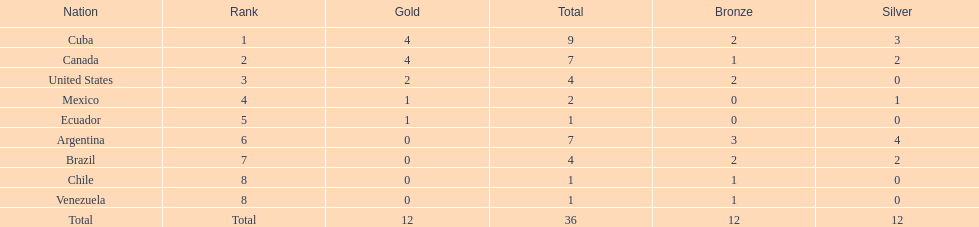Which country won the largest haul of bronze medals? Argentina. 